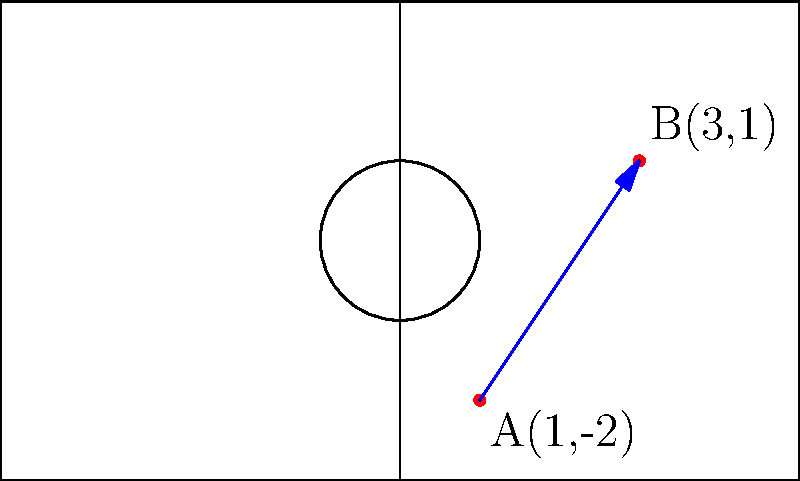During a training session, you're analyzing a young player's diagonal run across the field. The player starts at point A(1,-2) and ends at point B(3,1) on the coordinate plane representing the soccer field. Calculate the slope of the line representing the player's run. How would you interpret this slope in terms of the player's movement? To find the slope of the line representing the player's run, we'll use the slope formula:

$$ m = \frac{y_2 - y_1}{x_2 - x_1} $$

Where $(x_1, y_1)$ is the starting point A, and $(x_2, y_2)$ is the ending point B.

Step 1: Identify the coordinates
A(1, -2) : $x_1 = 1$, $y_1 = -2$
B(3, 1) : $x_2 = 3$, $y_2 = 1$

Step 2: Apply the slope formula
$$ m = \frac{y_2 - y_1}{x_2 - x_1} = \frac{1 - (-2)}{3 - 1} = \frac{3}{2} = 1.5 $$

Step 3: Interpret the slope
The slope of 1.5 means that for every 1 unit the player moves horizontally (along the x-axis), they move 1.5 units vertically (along the y-axis). In soccer terms, this indicates a diagonal run where the player is moving upfield (positive y direction) faster than they are moving across the field (x direction).

A positive slope shows that the player is moving upfield while also moving from left to right. This could represent a forward making a run into space or a midfielder moving into an attacking position.
Answer: Slope = 1.5; represents diagonal upfield run, more vertical than horizontal movement. 